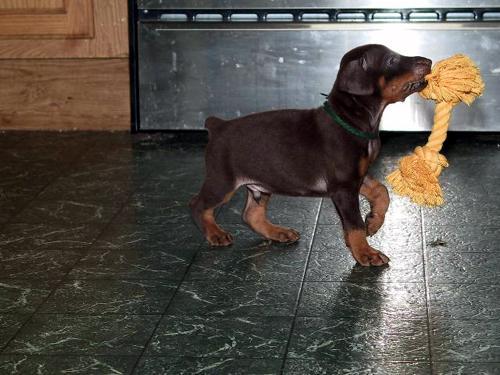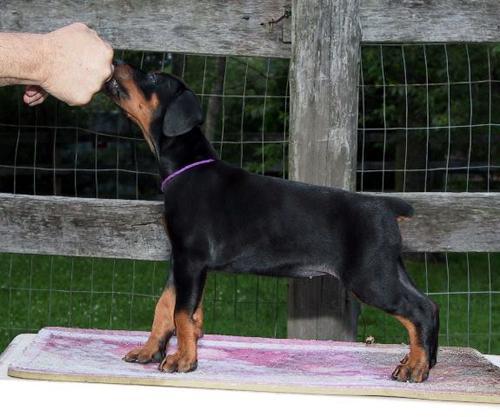The first image is the image on the left, the second image is the image on the right. Examine the images to the left and right. Is the description "A dog's full face is visible." accurate? Answer yes or no. No. The first image is the image on the left, the second image is the image on the right. Considering the images on both sides, is "Each image shows a dog standing in profile, and the dogs in the left and right images have their bodies turned toward each other." valid? Answer yes or no. Yes. 